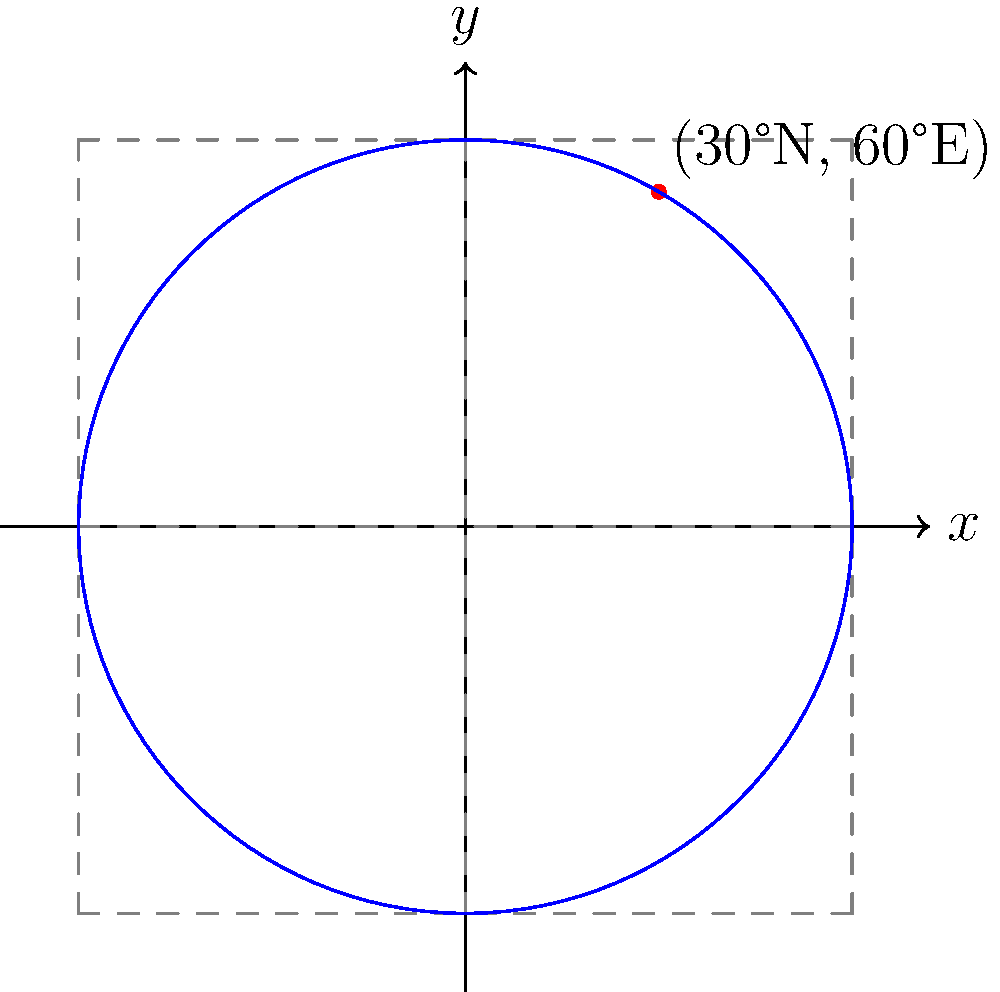In an old newspaper weather report, you find coordinates for a significant meteorological event: 30°N latitude, 60°E longitude. If you were to plot this point on an azimuthal equidistant projection centered at the North Pole, what would be its approximate (x, y) coordinates on a unit circle, where the equator forms the circumference? To solve this problem, we need to follow these steps:

1) In an azimuthal equidistant projection centered at the North Pole, latitude lines become concentric circles, and longitude lines become straight lines radiating from the center.

2) The distance from the center (North Pole) to any point is proportional to its co-latitude (90° - latitude). Here, co-latitude = 90° - 30° = 60°.

3) On a unit circle, the equator (co-latitude 90°) forms the circumference. So, our point will be 60/90 = 2/3 of the way from the center to the edge of the circle.

4) The angle from the positive x-axis is given by the longitude. 60°E is 60° counterclockwise from the positive x-axis.

5) To find the (x, y) coordinates, we use trigonometry:
   $x = r \cos(\theta) = \frac{2}{3} \cos(60°) = \frac{2}{3} \cdot \frac{1}{2} = \frac{1}{3}$
   $y = r \sin(\theta) = \frac{2}{3} \sin(60°) = \frac{2}{3} \cdot \frac{\sqrt{3}}{2} = \frac{\sqrt{3}}{3}$

6) Therefore, the approximate coordinates are $(\frac{1}{3}, \frac{\sqrt{3}}{3})$.
Answer: $(\frac{1}{3}, \frac{\sqrt{3}}{3})$ 